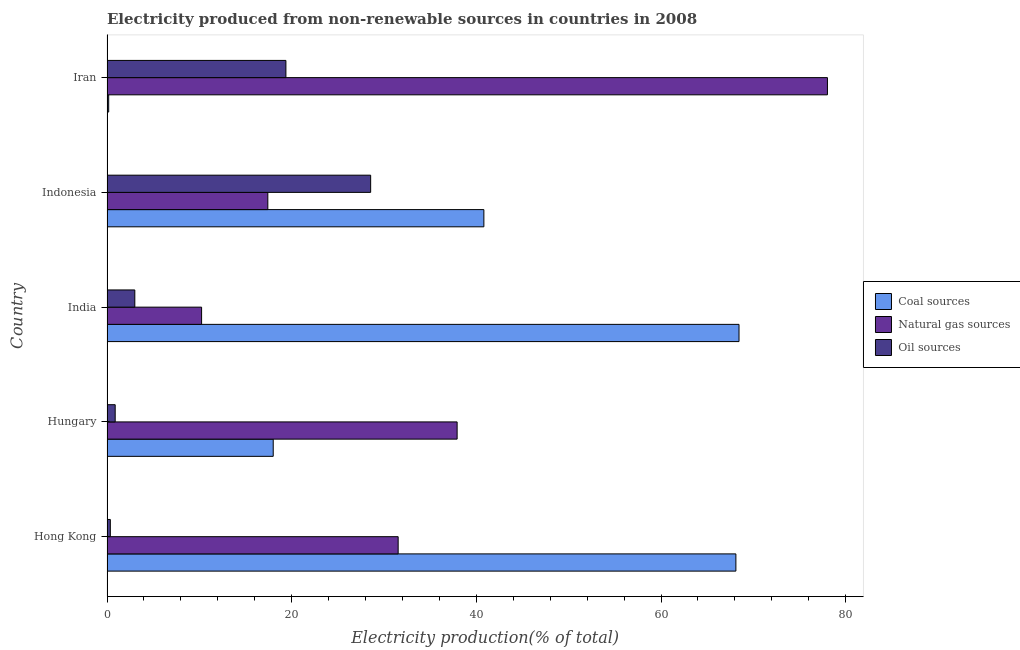How many different coloured bars are there?
Ensure brevity in your answer.  3. How many groups of bars are there?
Offer a very short reply. 5. Are the number of bars on each tick of the Y-axis equal?
Offer a terse response. Yes. How many bars are there on the 2nd tick from the top?
Offer a very short reply. 3. How many bars are there on the 3rd tick from the bottom?
Offer a very short reply. 3. What is the label of the 1st group of bars from the top?
Offer a very short reply. Iran. What is the percentage of electricity produced by coal in India?
Offer a terse response. 68.44. Across all countries, what is the maximum percentage of electricity produced by oil sources?
Keep it short and to the point. 28.55. Across all countries, what is the minimum percentage of electricity produced by coal?
Your response must be concise. 0.18. In which country was the percentage of electricity produced by coal maximum?
Give a very brief answer. India. In which country was the percentage of electricity produced by natural gas minimum?
Give a very brief answer. India. What is the total percentage of electricity produced by oil sources in the graph?
Provide a succinct answer. 52.19. What is the difference between the percentage of electricity produced by oil sources in Iran and the percentage of electricity produced by coal in Indonesia?
Your answer should be compact. -21.44. What is the average percentage of electricity produced by natural gas per country?
Ensure brevity in your answer.  35.03. What is the difference between the percentage of electricity produced by coal and percentage of electricity produced by natural gas in Hungary?
Your answer should be compact. -19.91. In how many countries, is the percentage of electricity produced by oil sources greater than 20 %?
Ensure brevity in your answer.  1. What is the ratio of the percentage of electricity produced by oil sources in Hong Kong to that in Hungary?
Keep it short and to the point. 0.41. What is the difference between the highest and the second highest percentage of electricity produced by oil sources?
Keep it short and to the point. 9.18. What is the difference between the highest and the lowest percentage of electricity produced by natural gas?
Provide a succinct answer. 67.78. In how many countries, is the percentage of electricity produced by coal greater than the average percentage of electricity produced by coal taken over all countries?
Your response must be concise. 3. What does the 3rd bar from the top in Iran represents?
Offer a terse response. Coal sources. What does the 2nd bar from the bottom in Indonesia represents?
Provide a short and direct response. Natural gas sources. Are all the bars in the graph horizontal?
Your answer should be very brief. Yes. Does the graph contain any zero values?
Ensure brevity in your answer.  No. Does the graph contain grids?
Ensure brevity in your answer.  No. Where does the legend appear in the graph?
Your answer should be very brief. Center right. What is the title of the graph?
Keep it short and to the point. Electricity produced from non-renewable sources in countries in 2008. What is the label or title of the X-axis?
Your response must be concise. Electricity production(% of total). What is the label or title of the Y-axis?
Your response must be concise. Country. What is the Electricity production(% of total) of Coal sources in Hong Kong?
Provide a succinct answer. 68.11. What is the Electricity production(% of total) in Natural gas sources in Hong Kong?
Offer a very short reply. 31.53. What is the Electricity production(% of total) of Oil sources in Hong Kong?
Offer a terse response. 0.36. What is the Electricity production(% of total) in Coal sources in Hungary?
Offer a terse response. 18. What is the Electricity production(% of total) in Natural gas sources in Hungary?
Offer a terse response. 37.92. What is the Electricity production(% of total) of Oil sources in Hungary?
Make the answer very short. 0.89. What is the Electricity production(% of total) of Coal sources in India?
Your answer should be compact. 68.44. What is the Electricity production(% of total) of Natural gas sources in India?
Your answer should be compact. 10.24. What is the Electricity production(% of total) of Oil sources in India?
Keep it short and to the point. 3.01. What is the Electricity production(% of total) in Coal sources in Indonesia?
Your answer should be compact. 40.81. What is the Electricity production(% of total) of Natural gas sources in Indonesia?
Offer a terse response. 17.42. What is the Electricity production(% of total) of Oil sources in Indonesia?
Keep it short and to the point. 28.55. What is the Electricity production(% of total) in Coal sources in Iran?
Offer a very short reply. 0.18. What is the Electricity production(% of total) of Natural gas sources in Iran?
Provide a succinct answer. 78.02. What is the Electricity production(% of total) in Oil sources in Iran?
Make the answer very short. 19.37. Across all countries, what is the maximum Electricity production(% of total) in Coal sources?
Keep it short and to the point. 68.44. Across all countries, what is the maximum Electricity production(% of total) in Natural gas sources?
Provide a short and direct response. 78.02. Across all countries, what is the maximum Electricity production(% of total) of Oil sources?
Give a very brief answer. 28.55. Across all countries, what is the minimum Electricity production(% of total) in Coal sources?
Offer a very short reply. 0.18. Across all countries, what is the minimum Electricity production(% of total) of Natural gas sources?
Keep it short and to the point. 10.24. Across all countries, what is the minimum Electricity production(% of total) of Oil sources?
Provide a short and direct response. 0.36. What is the total Electricity production(% of total) in Coal sources in the graph?
Keep it short and to the point. 195.55. What is the total Electricity production(% of total) of Natural gas sources in the graph?
Your response must be concise. 175.13. What is the total Electricity production(% of total) of Oil sources in the graph?
Your response must be concise. 52.19. What is the difference between the Electricity production(% of total) in Coal sources in Hong Kong and that in Hungary?
Your response must be concise. 50.1. What is the difference between the Electricity production(% of total) in Natural gas sources in Hong Kong and that in Hungary?
Provide a succinct answer. -6.38. What is the difference between the Electricity production(% of total) in Oil sources in Hong Kong and that in Hungary?
Provide a succinct answer. -0.53. What is the difference between the Electricity production(% of total) of Coal sources in Hong Kong and that in India?
Give a very brief answer. -0.34. What is the difference between the Electricity production(% of total) in Natural gas sources in Hong Kong and that in India?
Your answer should be compact. 21.29. What is the difference between the Electricity production(% of total) of Oil sources in Hong Kong and that in India?
Offer a very short reply. -2.65. What is the difference between the Electricity production(% of total) of Coal sources in Hong Kong and that in Indonesia?
Offer a very short reply. 27.29. What is the difference between the Electricity production(% of total) in Natural gas sources in Hong Kong and that in Indonesia?
Ensure brevity in your answer.  14.12. What is the difference between the Electricity production(% of total) in Oil sources in Hong Kong and that in Indonesia?
Your answer should be compact. -28.19. What is the difference between the Electricity production(% of total) of Coal sources in Hong Kong and that in Iran?
Give a very brief answer. 67.92. What is the difference between the Electricity production(% of total) in Natural gas sources in Hong Kong and that in Iran?
Provide a short and direct response. -46.49. What is the difference between the Electricity production(% of total) in Oil sources in Hong Kong and that in Iran?
Offer a very short reply. -19.01. What is the difference between the Electricity production(% of total) in Coal sources in Hungary and that in India?
Provide a short and direct response. -50.44. What is the difference between the Electricity production(% of total) of Natural gas sources in Hungary and that in India?
Your answer should be compact. 27.67. What is the difference between the Electricity production(% of total) in Oil sources in Hungary and that in India?
Make the answer very short. -2.13. What is the difference between the Electricity production(% of total) of Coal sources in Hungary and that in Indonesia?
Offer a terse response. -22.81. What is the difference between the Electricity production(% of total) of Natural gas sources in Hungary and that in Indonesia?
Keep it short and to the point. 20.5. What is the difference between the Electricity production(% of total) in Oil sources in Hungary and that in Indonesia?
Offer a very short reply. -27.67. What is the difference between the Electricity production(% of total) in Coal sources in Hungary and that in Iran?
Your answer should be very brief. 17.82. What is the difference between the Electricity production(% of total) of Natural gas sources in Hungary and that in Iran?
Keep it short and to the point. -40.1. What is the difference between the Electricity production(% of total) in Oil sources in Hungary and that in Iran?
Provide a succinct answer. -18.49. What is the difference between the Electricity production(% of total) of Coal sources in India and that in Indonesia?
Ensure brevity in your answer.  27.63. What is the difference between the Electricity production(% of total) of Natural gas sources in India and that in Indonesia?
Ensure brevity in your answer.  -7.17. What is the difference between the Electricity production(% of total) of Oil sources in India and that in Indonesia?
Ensure brevity in your answer.  -25.54. What is the difference between the Electricity production(% of total) in Coal sources in India and that in Iran?
Your answer should be very brief. 68.26. What is the difference between the Electricity production(% of total) of Natural gas sources in India and that in Iran?
Offer a very short reply. -67.78. What is the difference between the Electricity production(% of total) of Oil sources in India and that in Iran?
Your answer should be compact. -16.36. What is the difference between the Electricity production(% of total) of Coal sources in Indonesia and that in Iran?
Your answer should be very brief. 40.63. What is the difference between the Electricity production(% of total) of Natural gas sources in Indonesia and that in Iran?
Offer a terse response. -60.6. What is the difference between the Electricity production(% of total) of Oil sources in Indonesia and that in Iran?
Your answer should be very brief. 9.18. What is the difference between the Electricity production(% of total) in Coal sources in Hong Kong and the Electricity production(% of total) in Natural gas sources in Hungary?
Provide a succinct answer. 30.19. What is the difference between the Electricity production(% of total) of Coal sources in Hong Kong and the Electricity production(% of total) of Oil sources in Hungary?
Provide a short and direct response. 67.22. What is the difference between the Electricity production(% of total) in Natural gas sources in Hong Kong and the Electricity production(% of total) in Oil sources in Hungary?
Give a very brief answer. 30.64. What is the difference between the Electricity production(% of total) in Coal sources in Hong Kong and the Electricity production(% of total) in Natural gas sources in India?
Make the answer very short. 57.86. What is the difference between the Electricity production(% of total) in Coal sources in Hong Kong and the Electricity production(% of total) in Oil sources in India?
Provide a short and direct response. 65.09. What is the difference between the Electricity production(% of total) of Natural gas sources in Hong Kong and the Electricity production(% of total) of Oil sources in India?
Keep it short and to the point. 28.52. What is the difference between the Electricity production(% of total) in Coal sources in Hong Kong and the Electricity production(% of total) in Natural gas sources in Indonesia?
Provide a short and direct response. 50.69. What is the difference between the Electricity production(% of total) in Coal sources in Hong Kong and the Electricity production(% of total) in Oil sources in Indonesia?
Provide a succinct answer. 39.55. What is the difference between the Electricity production(% of total) in Natural gas sources in Hong Kong and the Electricity production(% of total) in Oil sources in Indonesia?
Your response must be concise. 2.98. What is the difference between the Electricity production(% of total) of Coal sources in Hong Kong and the Electricity production(% of total) of Natural gas sources in Iran?
Give a very brief answer. -9.91. What is the difference between the Electricity production(% of total) in Coal sources in Hong Kong and the Electricity production(% of total) in Oil sources in Iran?
Make the answer very short. 48.73. What is the difference between the Electricity production(% of total) in Natural gas sources in Hong Kong and the Electricity production(% of total) in Oil sources in Iran?
Your answer should be very brief. 12.16. What is the difference between the Electricity production(% of total) of Coal sources in Hungary and the Electricity production(% of total) of Natural gas sources in India?
Your answer should be very brief. 7.76. What is the difference between the Electricity production(% of total) in Coal sources in Hungary and the Electricity production(% of total) in Oil sources in India?
Keep it short and to the point. 14.99. What is the difference between the Electricity production(% of total) in Natural gas sources in Hungary and the Electricity production(% of total) in Oil sources in India?
Keep it short and to the point. 34.9. What is the difference between the Electricity production(% of total) in Coal sources in Hungary and the Electricity production(% of total) in Natural gas sources in Indonesia?
Your response must be concise. 0.58. What is the difference between the Electricity production(% of total) of Coal sources in Hungary and the Electricity production(% of total) of Oil sources in Indonesia?
Your answer should be very brief. -10.55. What is the difference between the Electricity production(% of total) in Natural gas sources in Hungary and the Electricity production(% of total) in Oil sources in Indonesia?
Provide a short and direct response. 9.36. What is the difference between the Electricity production(% of total) in Coal sources in Hungary and the Electricity production(% of total) in Natural gas sources in Iran?
Ensure brevity in your answer.  -60.02. What is the difference between the Electricity production(% of total) in Coal sources in Hungary and the Electricity production(% of total) in Oil sources in Iran?
Keep it short and to the point. -1.37. What is the difference between the Electricity production(% of total) in Natural gas sources in Hungary and the Electricity production(% of total) in Oil sources in Iran?
Offer a terse response. 18.54. What is the difference between the Electricity production(% of total) of Coal sources in India and the Electricity production(% of total) of Natural gas sources in Indonesia?
Offer a very short reply. 51.03. What is the difference between the Electricity production(% of total) in Coal sources in India and the Electricity production(% of total) in Oil sources in Indonesia?
Your answer should be compact. 39.89. What is the difference between the Electricity production(% of total) in Natural gas sources in India and the Electricity production(% of total) in Oil sources in Indonesia?
Keep it short and to the point. -18.31. What is the difference between the Electricity production(% of total) of Coal sources in India and the Electricity production(% of total) of Natural gas sources in Iran?
Your answer should be very brief. -9.58. What is the difference between the Electricity production(% of total) in Coal sources in India and the Electricity production(% of total) in Oil sources in Iran?
Offer a terse response. 49.07. What is the difference between the Electricity production(% of total) of Natural gas sources in India and the Electricity production(% of total) of Oil sources in Iran?
Your answer should be compact. -9.13. What is the difference between the Electricity production(% of total) of Coal sources in Indonesia and the Electricity production(% of total) of Natural gas sources in Iran?
Provide a short and direct response. -37.21. What is the difference between the Electricity production(% of total) of Coal sources in Indonesia and the Electricity production(% of total) of Oil sources in Iran?
Your answer should be compact. 21.44. What is the difference between the Electricity production(% of total) in Natural gas sources in Indonesia and the Electricity production(% of total) in Oil sources in Iran?
Your response must be concise. -1.96. What is the average Electricity production(% of total) in Coal sources per country?
Give a very brief answer. 39.11. What is the average Electricity production(% of total) of Natural gas sources per country?
Give a very brief answer. 35.03. What is the average Electricity production(% of total) in Oil sources per country?
Offer a terse response. 10.44. What is the difference between the Electricity production(% of total) of Coal sources and Electricity production(% of total) of Natural gas sources in Hong Kong?
Ensure brevity in your answer.  36.57. What is the difference between the Electricity production(% of total) in Coal sources and Electricity production(% of total) in Oil sources in Hong Kong?
Provide a succinct answer. 67.74. What is the difference between the Electricity production(% of total) of Natural gas sources and Electricity production(% of total) of Oil sources in Hong Kong?
Your answer should be very brief. 31.17. What is the difference between the Electricity production(% of total) in Coal sources and Electricity production(% of total) in Natural gas sources in Hungary?
Offer a very short reply. -19.92. What is the difference between the Electricity production(% of total) of Coal sources and Electricity production(% of total) of Oil sources in Hungary?
Ensure brevity in your answer.  17.11. What is the difference between the Electricity production(% of total) of Natural gas sources and Electricity production(% of total) of Oil sources in Hungary?
Ensure brevity in your answer.  37.03. What is the difference between the Electricity production(% of total) of Coal sources and Electricity production(% of total) of Natural gas sources in India?
Ensure brevity in your answer.  58.2. What is the difference between the Electricity production(% of total) of Coal sources and Electricity production(% of total) of Oil sources in India?
Offer a very short reply. 65.43. What is the difference between the Electricity production(% of total) of Natural gas sources and Electricity production(% of total) of Oil sources in India?
Give a very brief answer. 7.23. What is the difference between the Electricity production(% of total) of Coal sources and Electricity production(% of total) of Natural gas sources in Indonesia?
Your answer should be compact. 23.4. What is the difference between the Electricity production(% of total) of Coal sources and Electricity production(% of total) of Oil sources in Indonesia?
Offer a very short reply. 12.26. What is the difference between the Electricity production(% of total) of Natural gas sources and Electricity production(% of total) of Oil sources in Indonesia?
Provide a succinct answer. -11.14. What is the difference between the Electricity production(% of total) in Coal sources and Electricity production(% of total) in Natural gas sources in Iran?
Offer a terse response. -77.84. What is the difference between the Electricity production(% of total) in Coal sources and Electricity production(% of total) in Oil sources in Iran?
Keep it short and to the point. -19.19. What is the difference between the Electricity production(% of total) of Natural gas sources and Electricity production(% of total) of Oil sources in Iran?
Your answer should be compact. 58.65. What is the ratio of the Electricity production(% of total) in Coal sources in Hong Kong to that in Hungary?
Your answer should be compact. 3.78. What is the ratio of the Electricity production(% of total) of Natural gas sources in Hong Kong to that in Hungary?
Your answer should be compact. 0.83. What is the ratio of the Electricity production(% of total) of Oil sources in Hong Kong to that in Hungary?
Give a very brief answer. 0.41. What is the ratio of the Electricity production(% of total) of Coal sources in Hong Kong to that in India?
Provide a short and direct response. 0.99. What is the ratio of the Electricity production(% of total) of Natural gas sources in Hong Kong to that in India?
Keep it short and to the point. 3.08. What is the ratio of the Electricity production(% of total) in Oil sources in Hong Kong to that in India?
Offer a very short reply. 0.12. What is the ratio of the Electricity production(% of total) of Coal sources in Hong Kong to that in Indonesia?
Ensure brevity in your answer.  1.67. What is the ratio of the Electricity production(% of total) of Natural gas sources in Hong Kong to that in Indonesia?
Your response must be concise. 1.81. What is the ratio of the Electricity production(% of total) in Oil sources in Hong Kong to that in Indonesia?
Make the answer very short. 0.01. What is the ratio of the Electricity production(% of total) of Coal sources in Hong Kong to that in Iran?
Your answer should be compact. 374.63. What is the ratio of the Electricity production(% of total) of Natural gas sources in Hong Kong to that in Iran?
Make the answer very short. 0.4. What is the ratio of the Electricity production(% of total) in Oil sources in Hong Kong to that in Iran?
Provide a short and direct response. 0.02. What is the ratio of the Electricity production(% of total) in Coal sources in Hungary to that in India?
Ensure brevity in your answer.  0.26. What is the ratio of the Electricity production(% of total) in Natural gas sources in Hungary to that in India?
Your answer should be very brief. 3.7. What is the ratio of the Electricity production(% of total) of Oil sources in Hungary to that in India?
Give a very brief answer. 0.29. What is the ratio of the Electricity production(% of total) of Coal sources in Hungary to that in Indonesia?
Keep it short and to the point. 0.44. What is the ratio of the Electricity production(% of total) of Natural gas sources in Hungary to that in Indonesia?
Offer a terse response. 2.18. What is the ratio of the Electricity production(% of total) in Oil sources in Hungary to that in Indonesia?
Offer a terse response. 0.03. What is the ratio of the Electricity production(% of total) in Coal sources in Hungary to that in Iran?
Make the answer very short. 99.02. What is the ratio of the Electricity production(% of total) in Natural gas sources in Hungary to that in Iran?
Your answer should be very brief. 0.49. What is the ratio of the Electricity production(% of total) of Oil sources in Hungary to that in Iran?
Provide a short and direct response. 0.05. What is the ratio of the Electricity production(% of total) of Coal sources in India to that in Indonesia?
Keep it short and to the point. 1.68. What is the ratio of the Electricity production(% of total) of Natural gas sources in India to that in Indonesia?
Give a very brief answer. 0.59. What is the ratio of the Electricity production(% of total) of Oil sources in India to that in Indonesia?
Provide a short and direct response. 0.11. What is the ratio of the Electricity production(% of total) in Coal sources in India to that in Iran?
Provide a short and direct response. 376.5. What is the ratio of the Electricity production(% of total) of Natural gas sources in India to that in Iran?
Make the answer very short. 0.13. What is the ratio of the Electricity production(% of total) in Oil sources in India to that in Iran?
Your answer should be compact. 0.16. What is the ratio of the Electricity production(% of total) of Coal sources in Indonesia to that in Iran?
Ensure brevity in your answer.  224.5. What is the ratio of the Electricity production(% of total) of Natural gas sources in Indonesia to that in Iran?
Make the answer very short. 0.22. What is the ratio of the Electricity production(% of total) in Oil sources in Indonesia to that in Iran?
Provide a succinct answer. 1.47. What is the difference between the highest and the second highest Electricity production(% of total) in Coal sources?
Ensure brevity in your answer.  0.34. What is the difference between the highest and the second highest Electricity production(% of total) in Natural gas sources?
Your response must be concise. 40.1. What is the difference between the highest and the second highest Electricity production(% of total) of Oil sources?
Your answer should be compact. 9.18. What is the difference between the highest and the lowest Electricity production(% of total) in Coal sources?
Ensure brevity in your answer.  68.26. What is the difference between the highest and the lowest Electricity production(% of total) of Natural gas sources?
Your answer should be very brief. 67.78. What is the difference between the highest and the lowest Electricity production(% of total) of Oil sources?
Give a very brief answer. 28.19. 